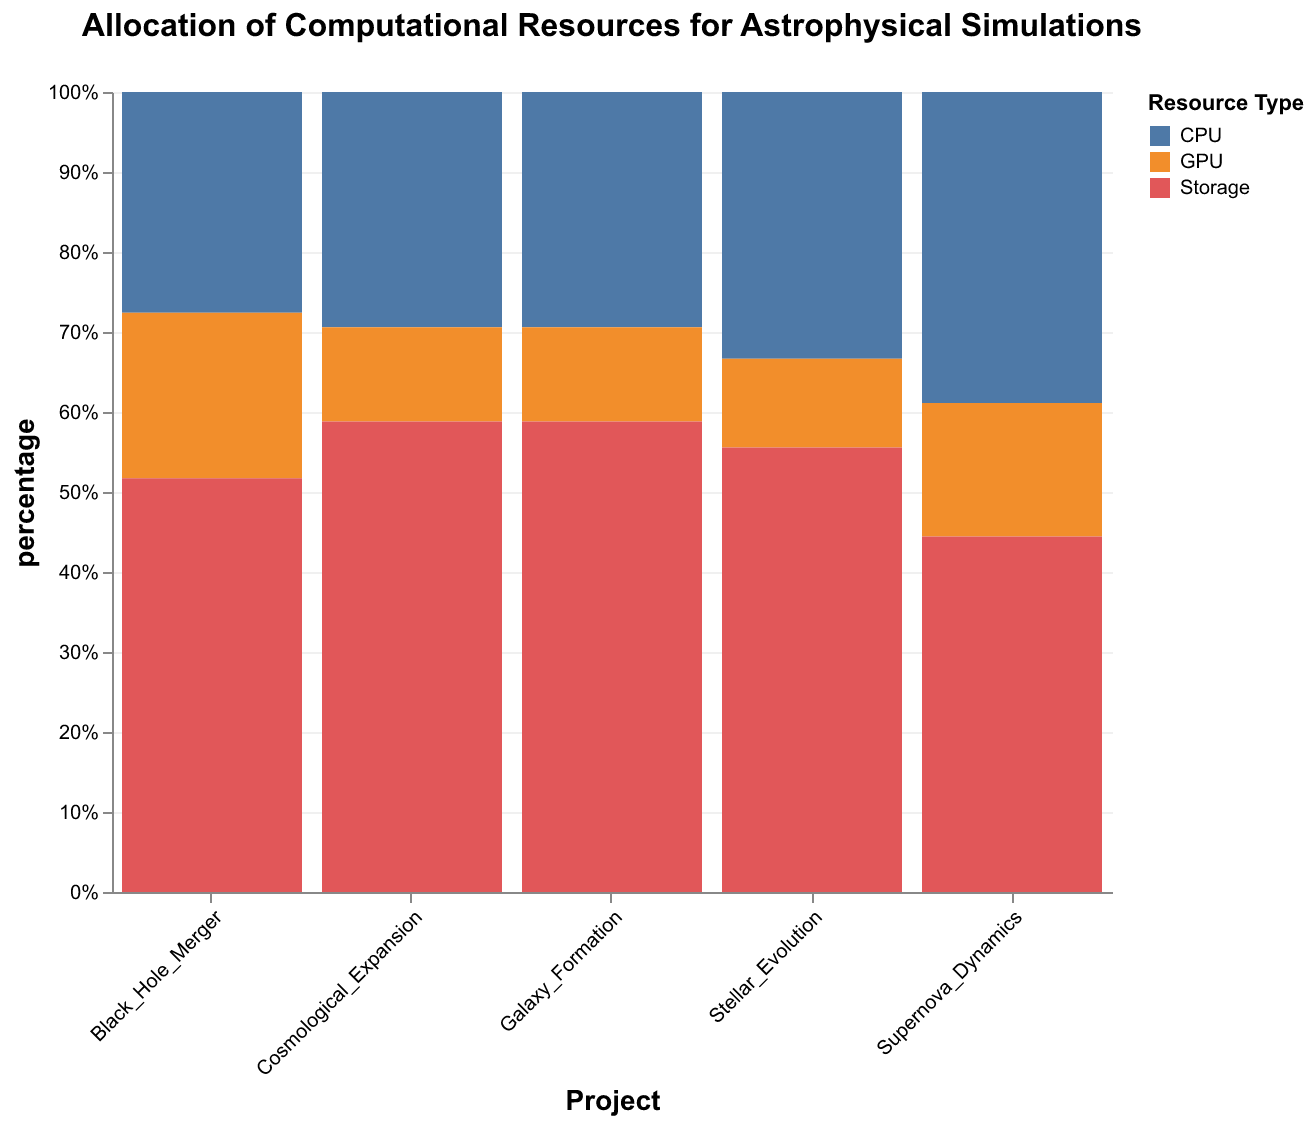What is the title of the plot? The title of the plot is the text displayed at the top of the figure which summarises its content.
Answer: Allocation of Computational Resources for Astrophysical Simulations What are the different resource types allocated in the projects? The resource types are denoted by different colors in the bar segments, and a legend on the right shows what each color represents.
Answer: CPU, GPU, Storage Which project received the highest allocation for storage? By examining the heights of the segments labeled 'Storage' in each project, the tallest segment indicates the highest allocation.
Answer: Cosmological Expansion Which two projects have the largest allocation for GPUs? The segments labeled 'GPU' for each project should be examined to find the two larger ones.
Answer: Black Hole Merger, Cosmological Expansion What percentage of its total resources does the Supernova Dynamics project allocate to CPUs? The height of the segment labeled 'CPU' in the Supernova Dynamics project divided by the total height of segments in that project gives the percentage.
Answer: 41.2% Arrange the projects by total computational resource allocation from highest to lowest. This can be determined by observing the total heights (stacked heights) of the segments corresponding to each project.
Answer: Cosmological Expansion, Black Hole Merger, Supernova Dynamics, Galaxy Formation, Stellar Evolution Which project has the smallest total resource allocation and what type of resource dominates in it? This can be found by identifying the project with the smallest overall bar height, and observing which segment type (color) is largest in that project.
Answer: Stellar Evolution, Storage What is the combined resource allocation for GPUs in all projects? Adding up the heights of all GPU segments across the different projects will give this value.
Answer: 160,000 hours Do any projects allocate more resources to GPUs than CPUs? By comparing the heights of GPU and CPU segments in each project, it can be checked if any GPU segment is taller.
Answer: No What project uses the largest percentage of its total resources for storage and what is that percentage? By finding the project with the tallest storage segment and dividing its height by the total height for that project, this percentage can be determined.
Answer: Cosmological Expansion, 50% 